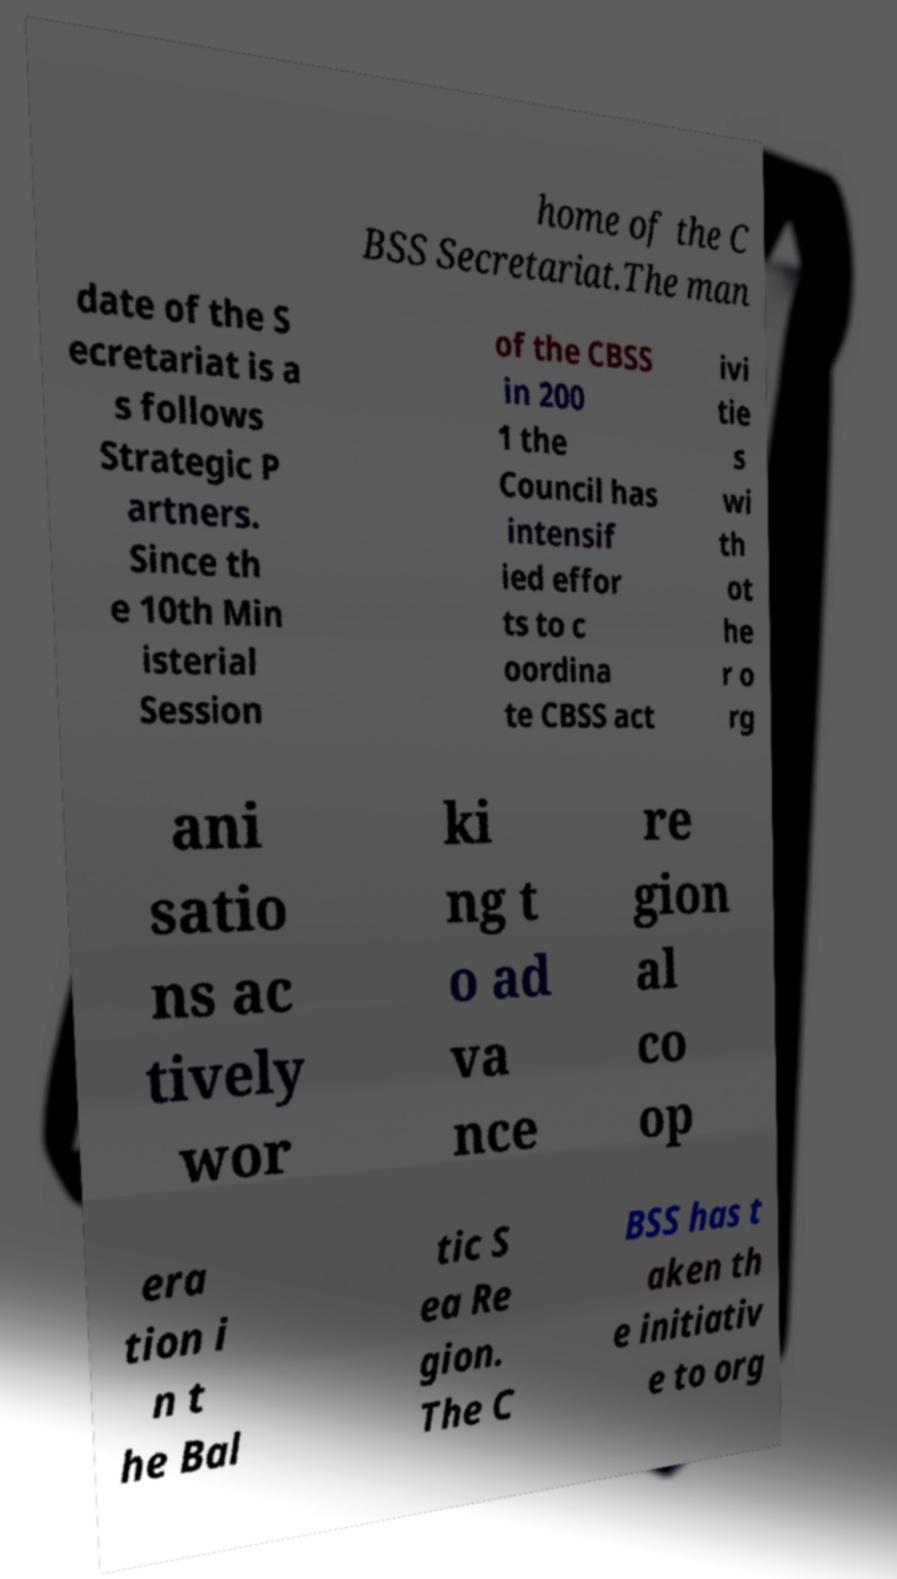Can you read and provide the text displayed in the image?This photo seems to have some interesting text. Can you extract and type it out for me? home of the C BSS Secretariat.The man date of the S ecretariat is a s follows Strategic P artners. Since th e 10th Min isterial Session of the CBSS in 200 1 the Council has intensif ied effor ts to c oordina te CBSS act ivi tie s wi th ot he r o rg ani satio ns ac tively wor ki ng t o ad va nce re gion al co op era tion i n t he Bal tic S ea Re gion. The C BSS has t aken th e initiativ e to org 